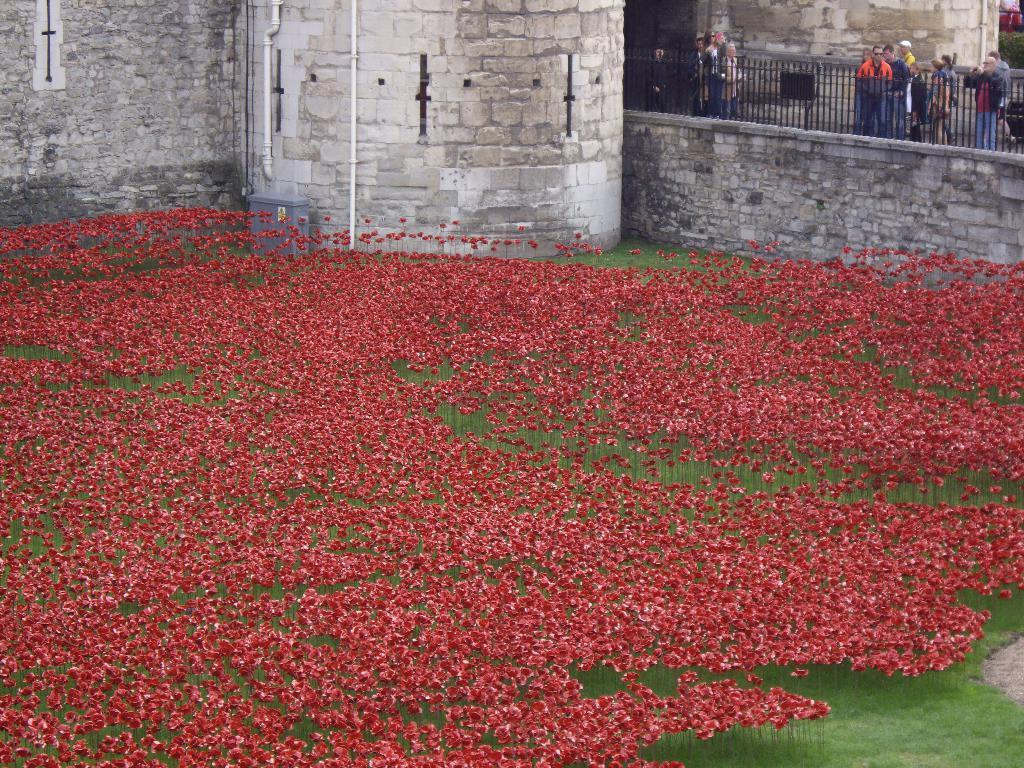Please provide a concise description of this image. In this image there are flowers, in the background there is a fort and a railing, behind the railing there are people standing. 